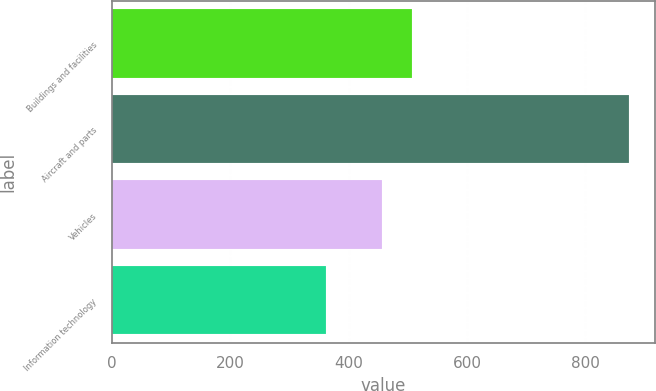<chart> <loc_0><loc_0><loc_500><loc_500><bar_chart><fcel>Buildings and facilities<fcel>Aircraft and parts<fcel>Vehicles<fcel>Information technology<nl><fcel>507.2<fcel>874<fcel>456<fcel>362<nl></chart> 